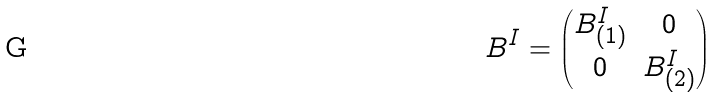Convert formula to latex. <formula><loc_0><loc_0><loc_500><loc_500>B ^ { I } = \begin{pmatrix} B ^ { I } _ { ( 1 ) } & 0 \\ 0 & B ^ { I } _ { ( 2 ) } \end{pmatrix}</formula> 